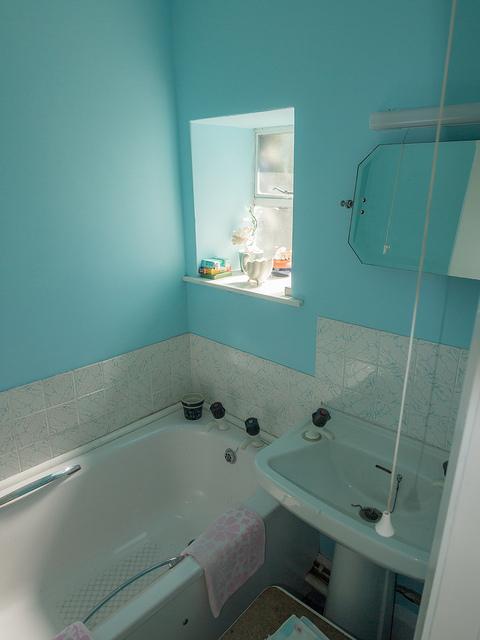How many bar of soaps are there?
Short answer required. 0. How many tiles on wall?
Concise answer only. Many. What room is this?
Give a very brief answer. Bathroom. What is the color scheme of the photo?
Give a very brief answer. Blue. How many soap dishes are on the wall?
Keep it brief. 0. What part of this room looks like it came from a Dr. Seuss book?
Concise answer only. Mirror. What color is the tub?
Answer briefly. White. 